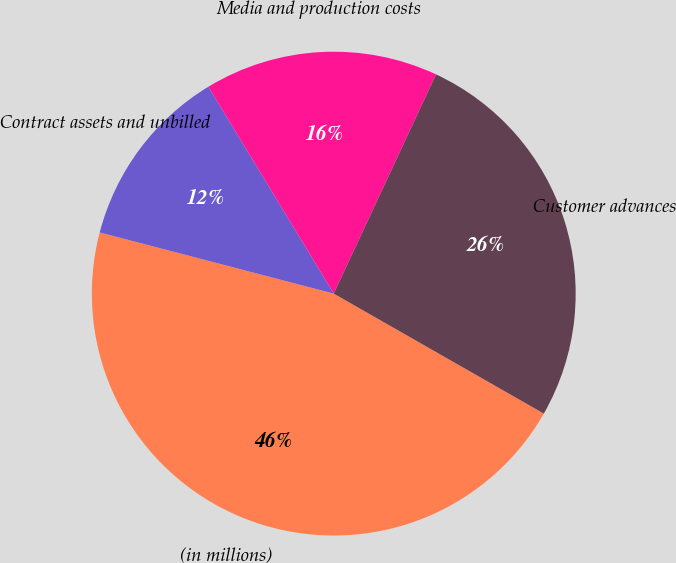Convert chart. <chart><loc_0><loc_0><loc_500><loc_500><pie_chart><fcel>(in millions)<fcel>Contract assets and unbilled<fcel>Media and production costs<fcel>Customer advances<nl><fcel>45.81%<fcel>12.26%<fcel>15.62%<fcel>26.31%<nl></chart> 